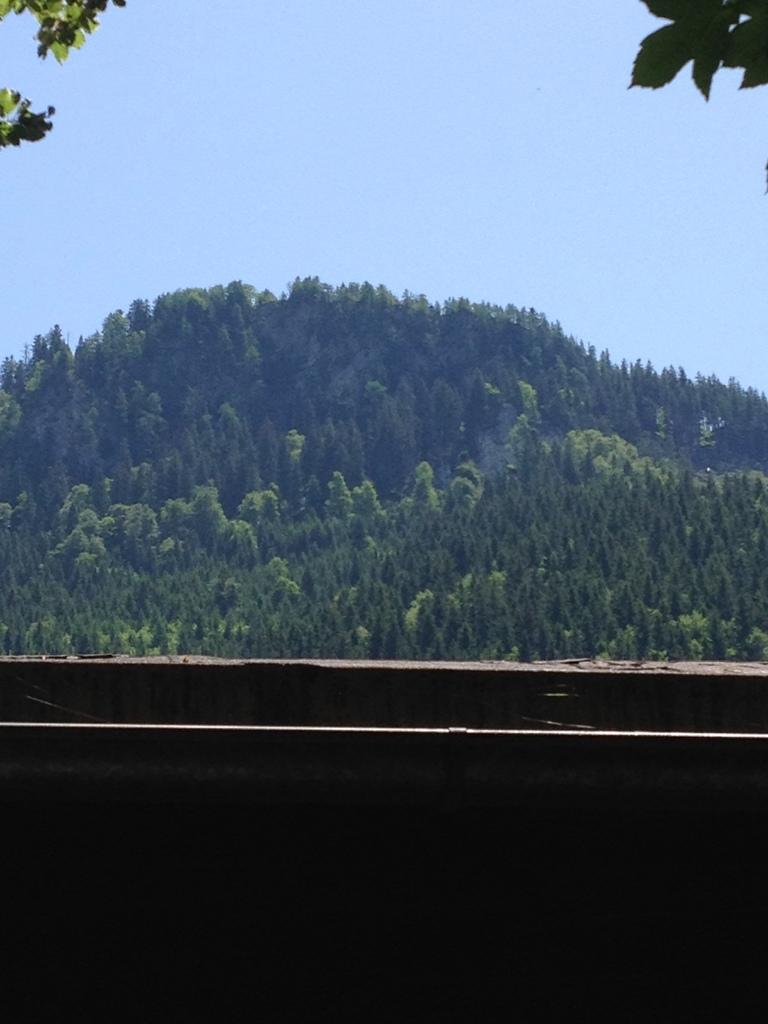What type of vegetation can be seen in the image? There are trees in the image. What geographical feature is present in the image? There is a hill in the image. How many apples are on the tray in the image? There is no tray or apples present in the image. What idea is being conveyed by the trees in the image? The image does not convey any specific idea; it simply depicts trees and a hill. 